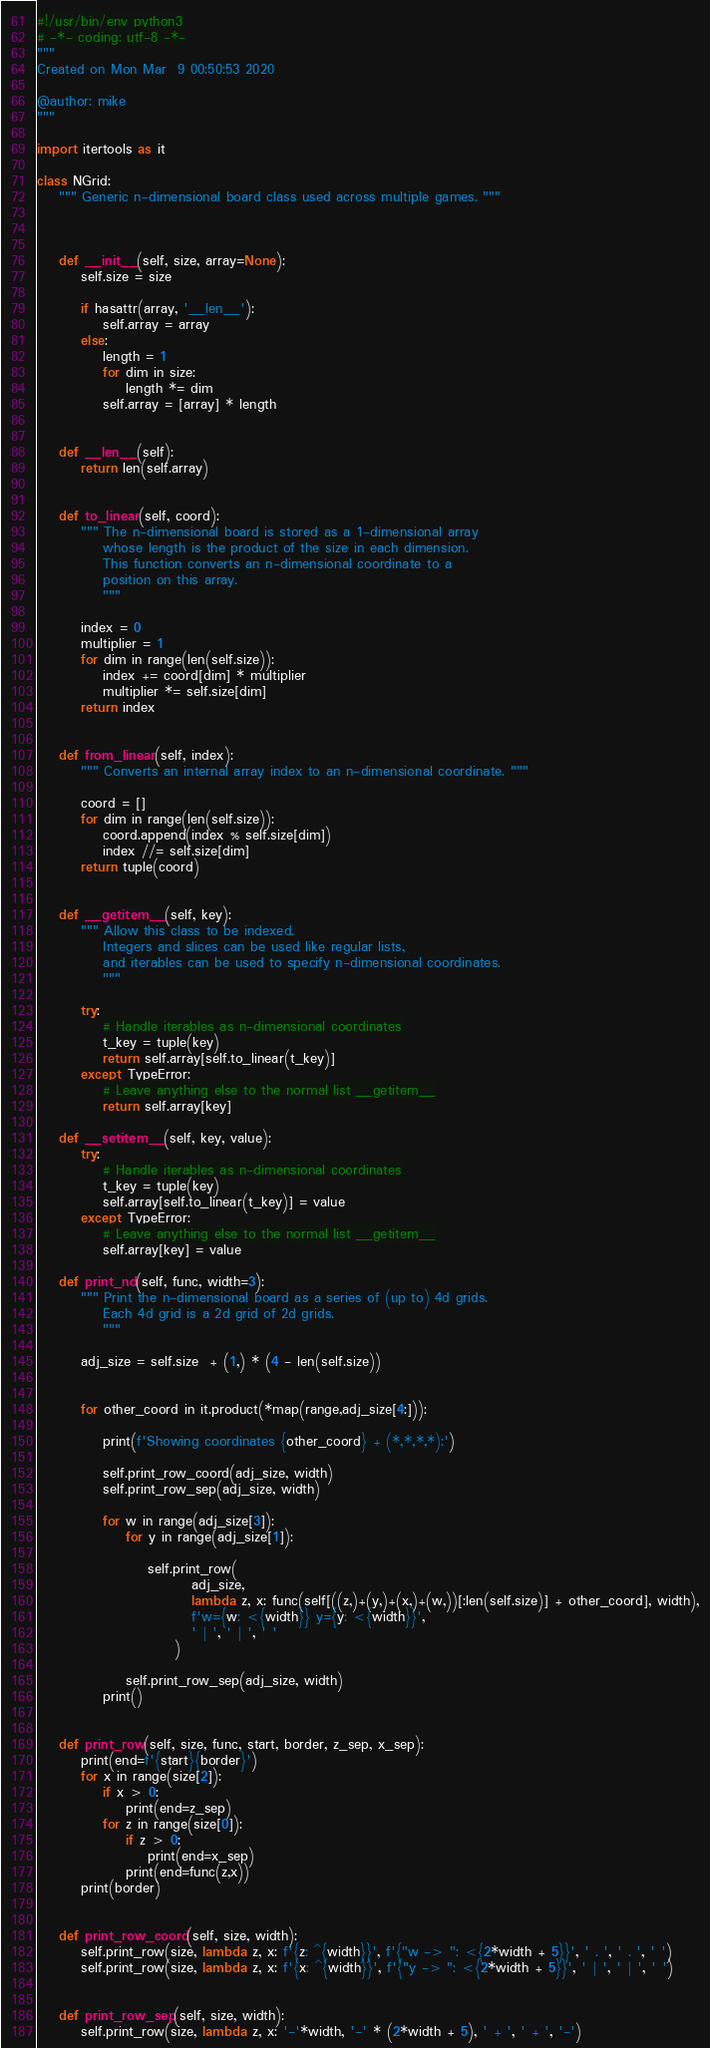<code> <loc_0><loc_0><loc_500><loc_500><_Python_>#!/usr/bin/env python3
# -*- coding: utf-8 -*-
"""
Created on Mon Mar  9 00:50:53 2020

@author: mike
"""

import itertools as it

class NGrid:
    """ Generic n-dimensional board class used across multiple games. """
    
    
    
    def __init__(self, size, array=None):
        self.size = size
        
        if hasattr(array, '__len__'):
            self.array = array
        else:
            length = 1
            for dim in size:
                length *= dim
            self.array = [array] * length
    
    
    def __len__(self):
        return len(self.array)


    def to_linear(self, coord):
        """ The n-dimensional board is stored as a 1-dimensional array
            whose length is the product of the size in each dimension.
            This function converts an n-dimensional coordinate to a
            position on this array.
            """
            
        index = 0
        multiplier = 1
        for dim in range(len(self.size)):
            index += coord[dim] * multiplier
            multiplier *= self.size[dim]
        return index
    
    
    def from_linear(self, index):
        """ Converts an internal array index to an n-dimensional coordinate. """
        
        coord = []
        for dim in range(len(self.size)):
            coord.append(index % self.size[dim])
            index //= self.size[dim]
        return tuple(coord)
    
    
    def __getitem__(self, key):
        """ Allow this class to be indexed.
            Integers and slices can be used like regular lists,
            and iterables can be used to specify n-dimensional coordinates.
            """
            
        try:
            # Handle iterables as n-dimensional coordinates
            t_key = tuple(key)
            return self.array[self.to_linear(t_key)]
        except TypeError:
            # Leave anything else to the normal list __getitem__
            return self.array[key]
        
    def __setitem__(self, key, value):
        try:
            # Handle iterables as n-dimensional coordinates
            t_key = tuple(key)
            self.array[self.to_linear(t_key)] = value
        except TypeError:
            # Leave anything else to the normal list __getitem__
            self.array[key] = value
        
    def print_nd(self, func, width=3):
        """ Print the n-dimensional board as a series of (up to) 4d grids.
            Each 4d grid is a 2d grid of 2d grids.
            """
        
        adj_size = self.size  + (1,) * (4 - len(self.size))
        
        
        for other_coord in it.product(*map(range,adj_size[4:])):
            
            print(f'Showing coordinates {other_coord} + (*,*,*,*):')
            
            self.print_row_coord(adj_size, width)
            self.print_row_sep(adj_size, width)
            
            for w in range(adj_size[3]):
                for y in range(adj_size[1]):
                    
                    self.print_row(
                            adj_size,
                            lambda z, x: func(self[((z,)+(y,)+(x,)+(w,))[:len(self.size)] + other_coord], width),
                            f'w={w: <{width}} y={y: <{width}}',
                            ' | ', ' | ', ' '
                         )
                    
                self.print_row_sep(adj_size, width)
            print()
            
          
    def print_row(self, size, func, start, border, z_sep, x_sep):
        print(end=f'{start}{border}')
        for x in range(size[2]):
            if x > 0:
                print(end=z_sep)
            for z in range(size[0]):
                if z > 0:
                    print(end=x_sep)
                print(end=func(z,x))
        print(border)
        
        
    def print_row_coord(self, size, width):
        self.print_row(size, lambda z, x: f'{z: ^{width}}', f'{"w -> ": <{2*width + 5}}', ' . ', ' . ', ' ')
        self.print_row(size, lambda z, x: f'{x: ^{width}}', f'{"y -> ": <{2*width + 5}}', ' | ', ' | ', ' ')
        
        
    def print_row_sep(self, size, width):
        self.print_row(size, lambda z, x: '-'*width, '-' * (2*width + 5), ' + ', ' + ', '-')</code> 